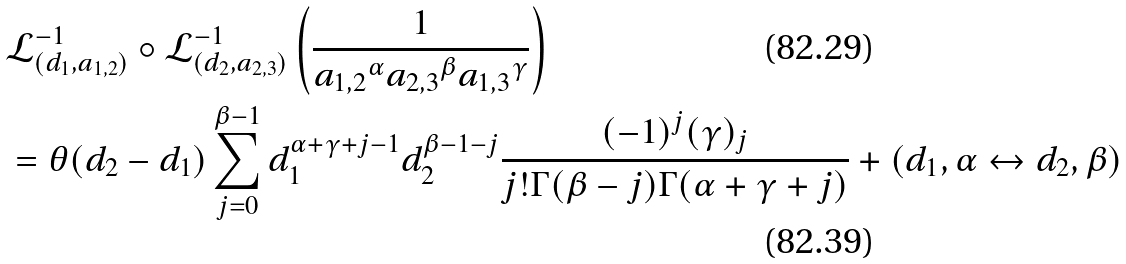Convert formula to latex. <formula><loc_0><loc_0><loc_500><loc_500>& { \mathcal { L } } _ { ( d _ { 1 } , a _ { 1 , 2 } ) } ^ { - 1 } \circ { \mathcal { L } } _ { ( d _ { 2 } , a _ { 2 , 3 } ) } ^ { - 1 } \left ( \frac { 1 } { { a _ { 1 , 2 } } ^ { \alpha } { a _ { 2 , 3 } } ^ { \beta } { a _ { 1 , 3 } } ^ { \gamma } } \right ) \\ & = \theta ( d _ { 2 } - d _ { 1 } ) \sum _ { j = 0 } ^ { \beta - 1 } d _ { 1 } ^ { \alpha + \gamma + j - 1 } d _ { 2 } ^ { \beta - 1 - j } \frac { ( - 1 ) ^ { j } ( \gamma ) _ { j } } { j ! \Gamma ( \beta - j ) \Gamma ( \alpha + \gamma + j ) } + ( d _ { 1 } , \alpha \leftrightarrow d _ { 2 } , \beta )</formula> 